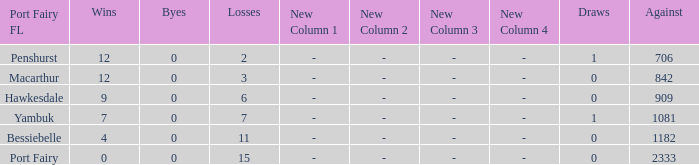I'm looking to parse the entire table for insights. Could you assist me with that? {'header': ['Port Fairy FL', 'Wins', 'Byes', 'Losses', 'New Column 1', 'New Column 2', 'New Column 3', 'New Column 4', 'Draws', 'Against'], 'rows': [['Penshurst', '12', '0', '2', '-', '-', '-', '-', '1', '706'], ['Macarthur', '12', '0', '3', '-', '-', '-', '-', '0', '842'], ['Hawkesdale', '9', '0', '6', '-', '-', '-', '-', '0', '909'], ['Yambuk', '7', '0', '7', '-', '-', '-', '-', '1', '1081'], ['Bessiebelle', '4', '0', '11', '-', '-', '-', '-', '0', '1182'], ['Port Fairy', '0', '0', '15', '-', '-', '-', '-', '0', '2333']]} How many wins for Port Fairy and against more than 2333? None. 